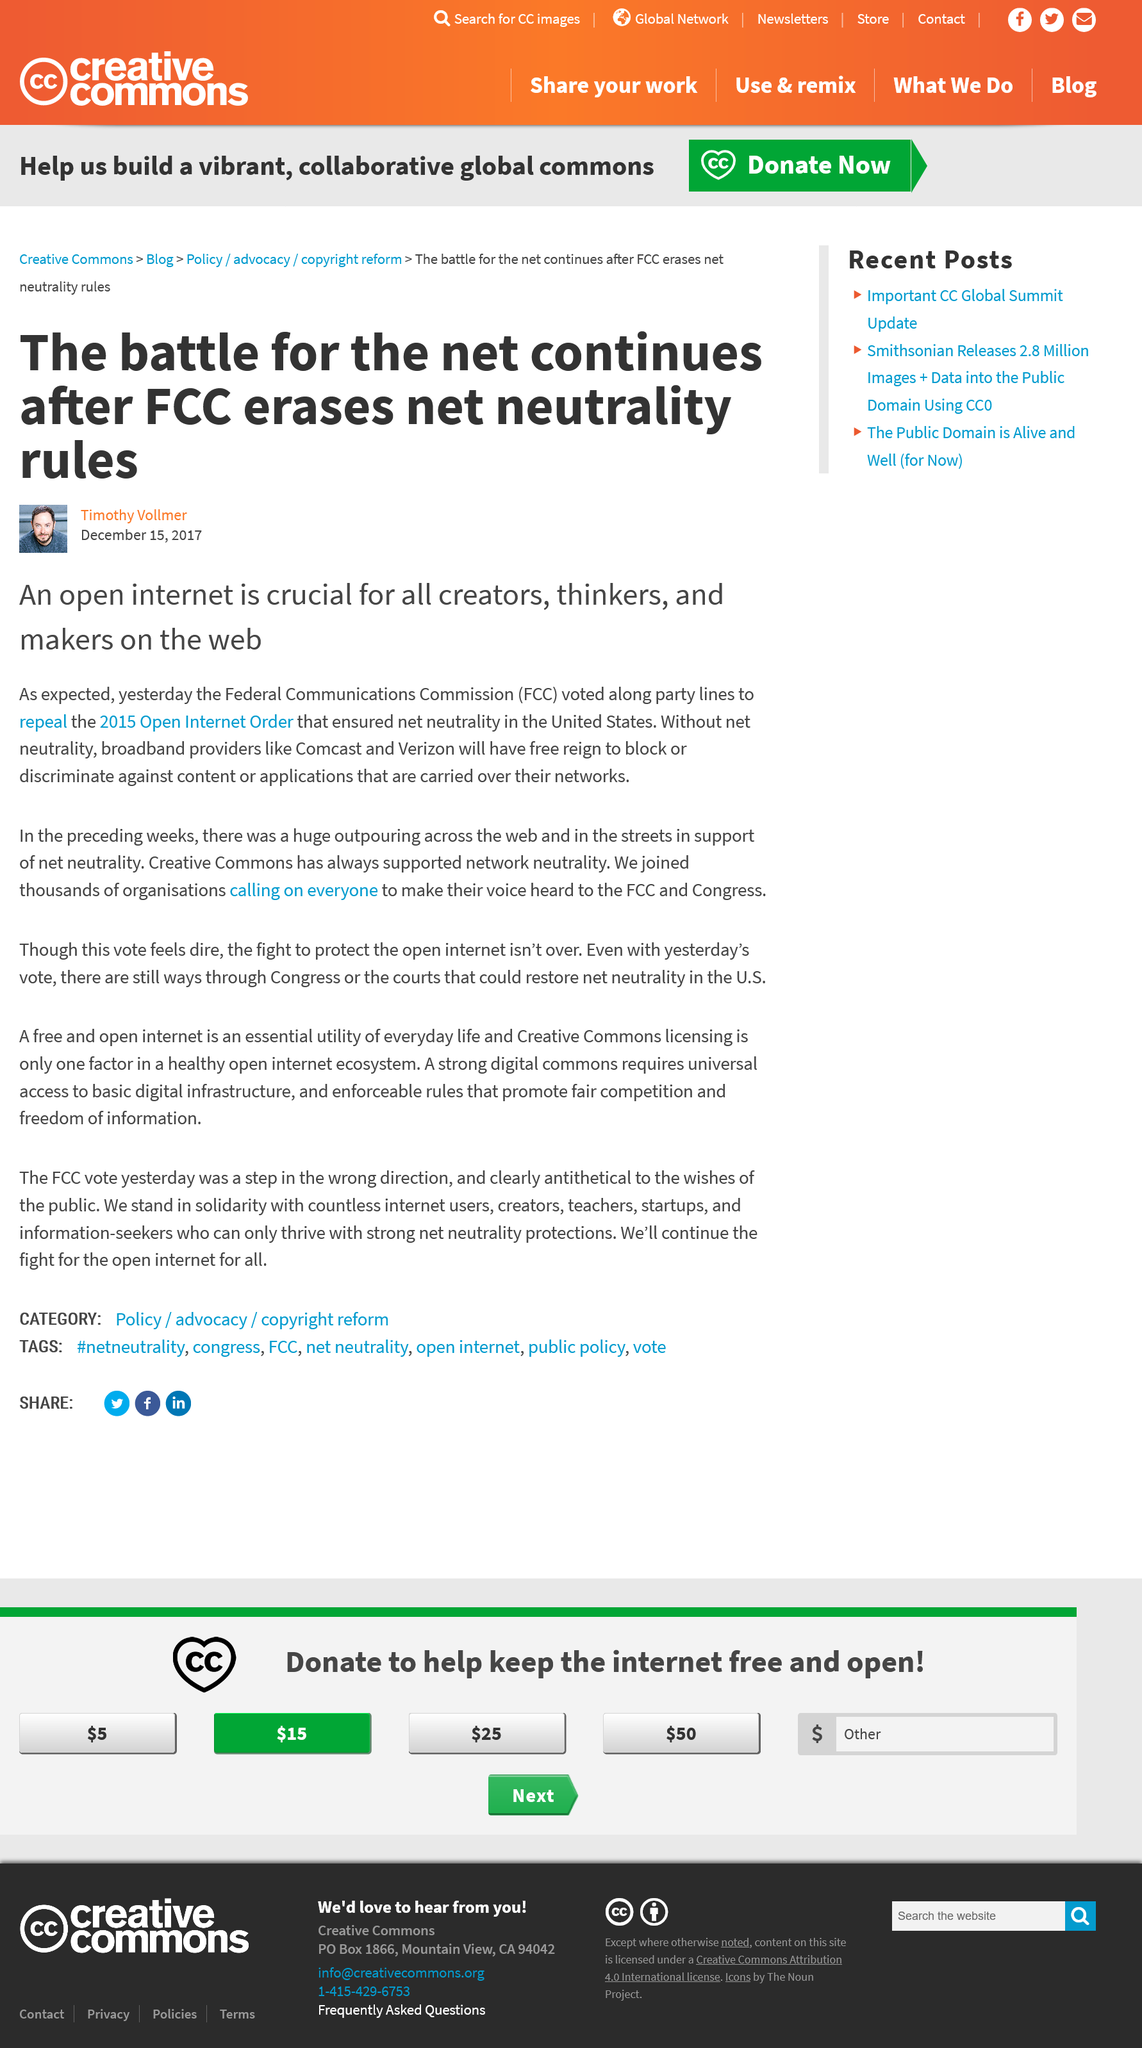Identify some key points in this picture. The vote took place in 2017. In 2015, the Open Internet Order was established. The Federal Communications Commission (FCC) voted to eliminate the existing net neutrality rules. 